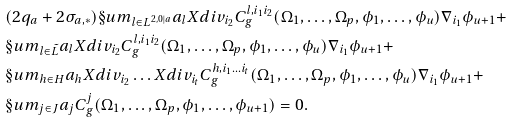Convert formula to latex. <formula><loc_0><loc_0><loc_500><loc_500>& ( 2 q _ { a } + 2 \sigma _ { a , * } ) \S u m _ { l \in L ^ { 2 , 0 | a } } a _ { l } X d i v _ { i _ { 2 } } C ^ { l , i _ { 1 } i _ { 2 } } _ { g } ( \Omega _ { 1 } , \dots , \Omega _ { p } , \phi _ { 1 } , \dots , \phi _ { u } ) \nabla _ { i _ { 1 } } \phi _ { u + 1 } + \\ & \S u m _ { l \in \tilde { L } } a _ { l } X d i v _ { i _ { 2 } } C ^ { l , i _ { 1 } i _ { 2 } } _ { g } ( \Omega _ { 1 } , \dots , \Omega _ { p } , \phi _ { 1 } , \dots , \phi _ { u } ) \nabla _ { i _ { 1 } } \phi _ { u + 1 } + \\ & \S u m _ { h \in H } a _ { h } X d i v _ { i _ { 2 } } \dots X d i v _ { i _ { t } } C ^ { h , i _ { 1 } \dots i _ { t } } _ { g } ( \Omega _ { 1 } , \dots , \Omega _ { p } , \phi _ { 1 } , \dots , \phi _ { u } ) \nabla _ { i _ { 1 } } \phi _ { u + 1 } + \\ & \S u m _ { j \in J } a _ { j } C ^ { j } _ { g } ( \Omega _ { 1 } , \dots , \Omega _ { p } , \phi _ { 1 } , \dots , \phi _ { u + 1 } ) = 0 .</formula> 